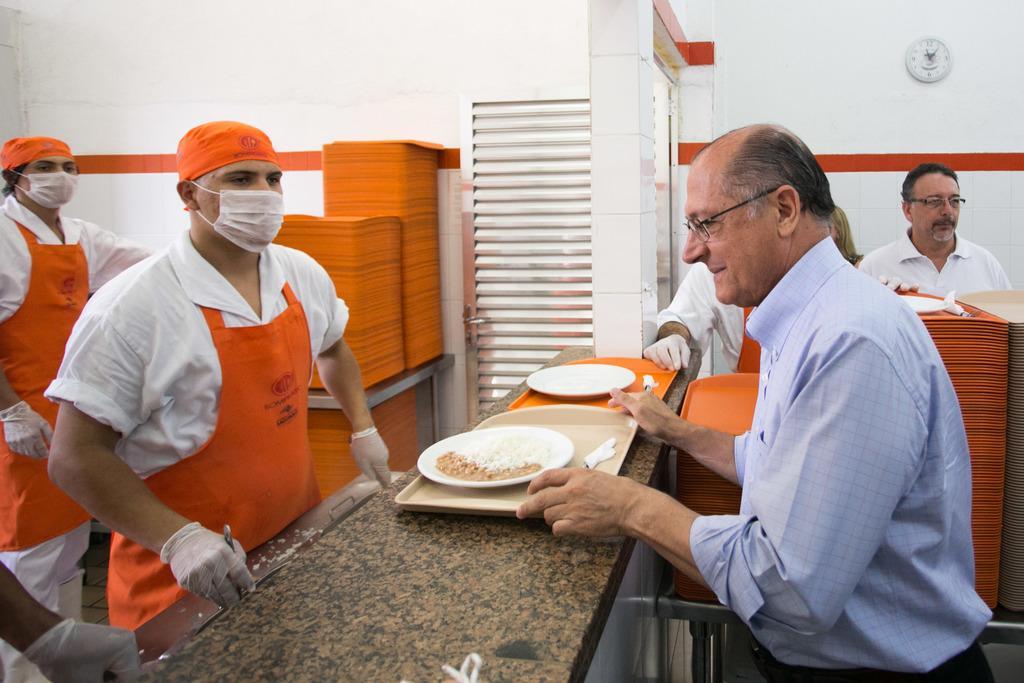Could you give a brief overview of what you see in this image? In this image we can see a person holding a tray which contains a plate with food items in it, around him there are people with a mask and a uniform, there are some trays placed on the table. 